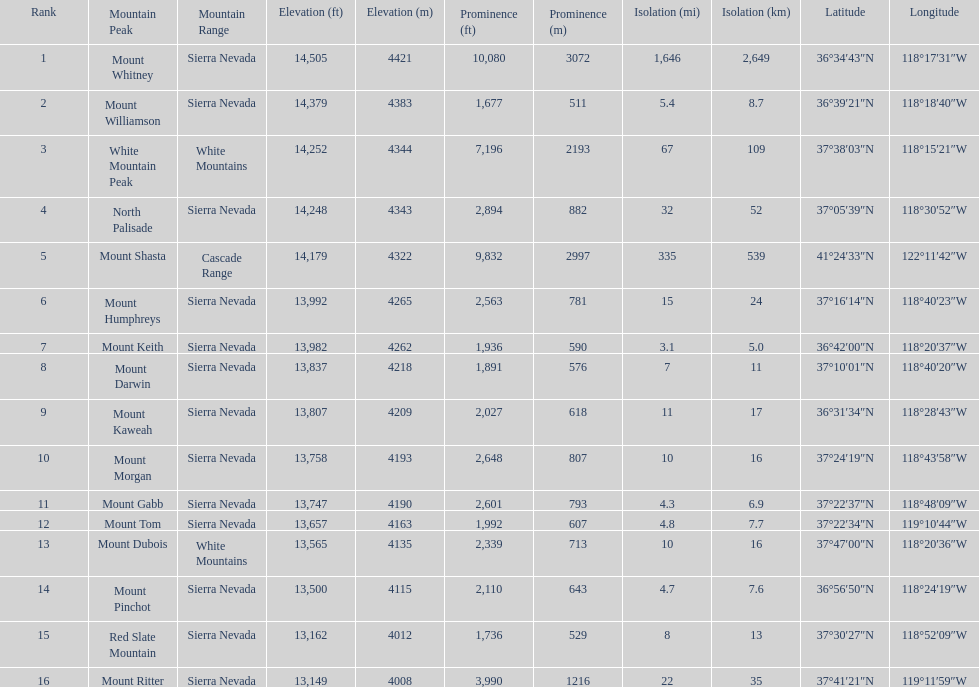Which mountain peak is no higher than 13,149 ft? Mount Ritter. 